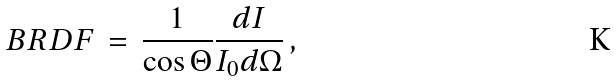<formula> <loc_0><loc_0><loc_500><loc_500>B R D F \, = \, \frac { 1 } { \cos \Theta } \frac { d I } { I _ { 0 } d \Omega } \, ,</formula> 